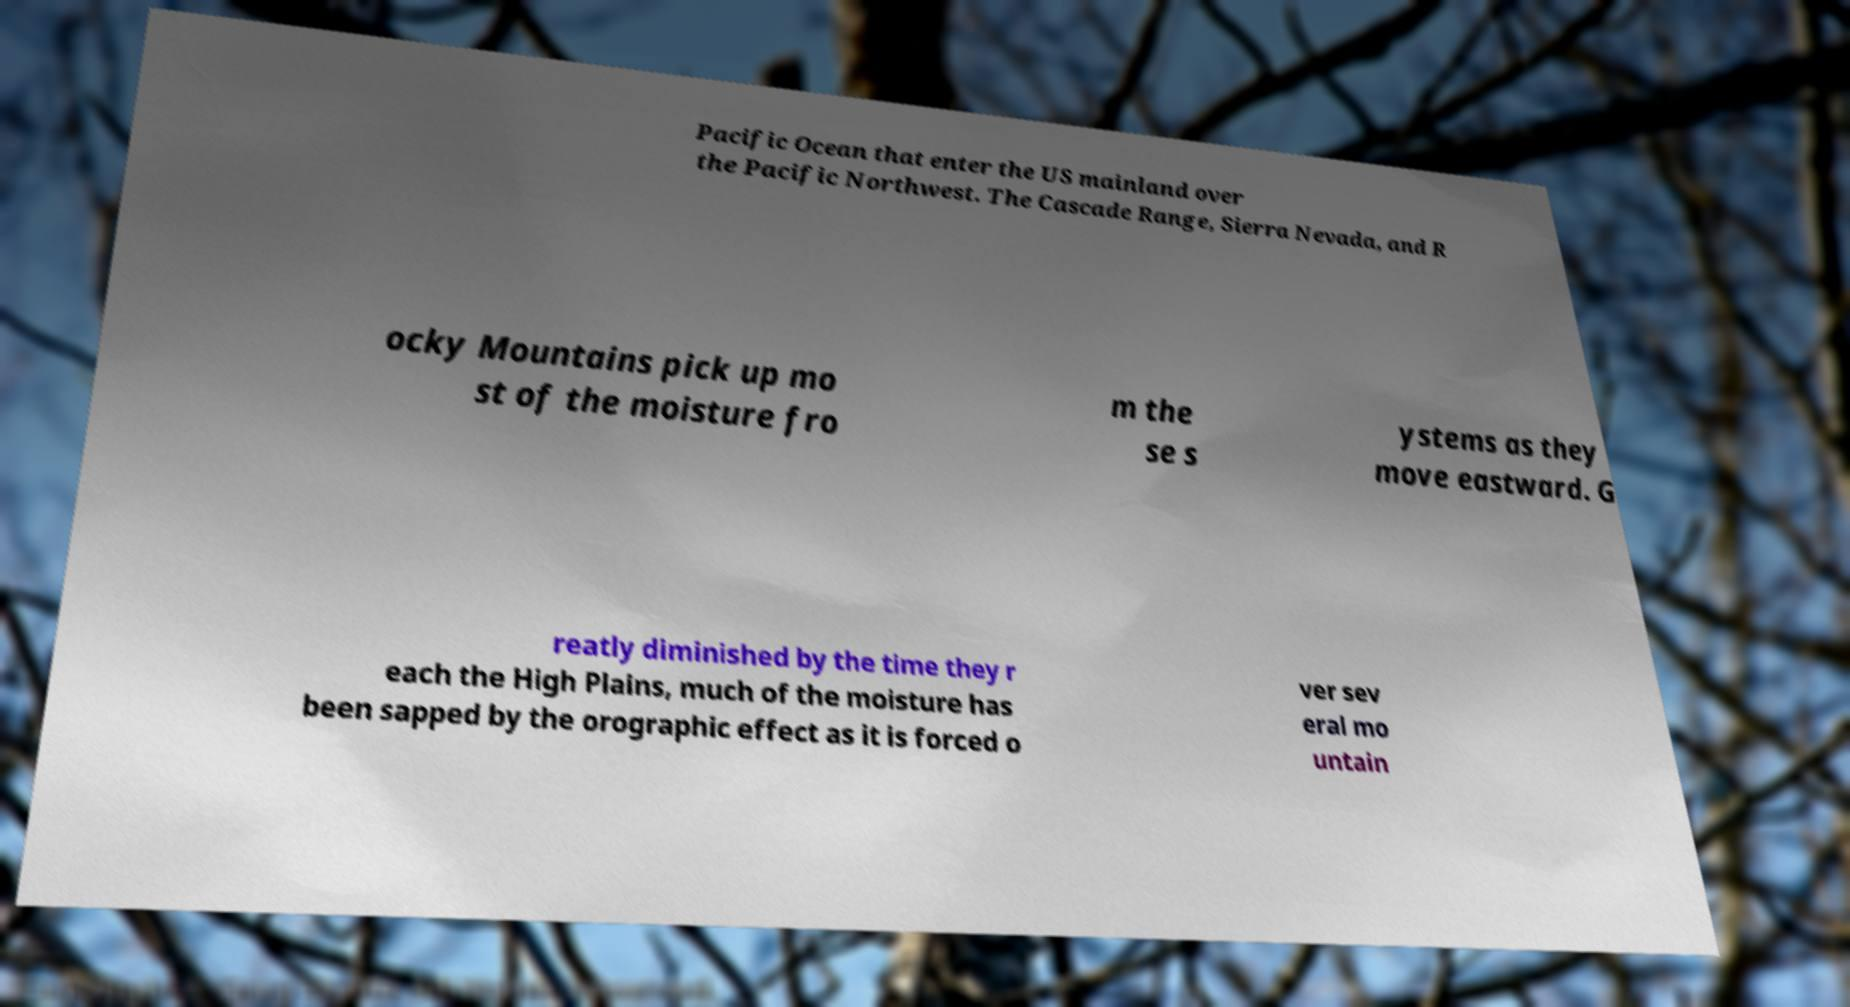Can you read and provide the text displayed in the image?This photo seems to have some interesting text. Can you extract and type it out for me? Pacific Ocean that enter the US mainland over the Pacific Northwest. The Cascade Range, Sierra Nevada, and R ocky Mountains pick up mo st of the moisture fro m the se s ystems as they move eastward. G reatly diminished by the time they r each the High Plains, much of the moisture has been sapped by the orographic effect as it is forced o ver sev eral mo untain 